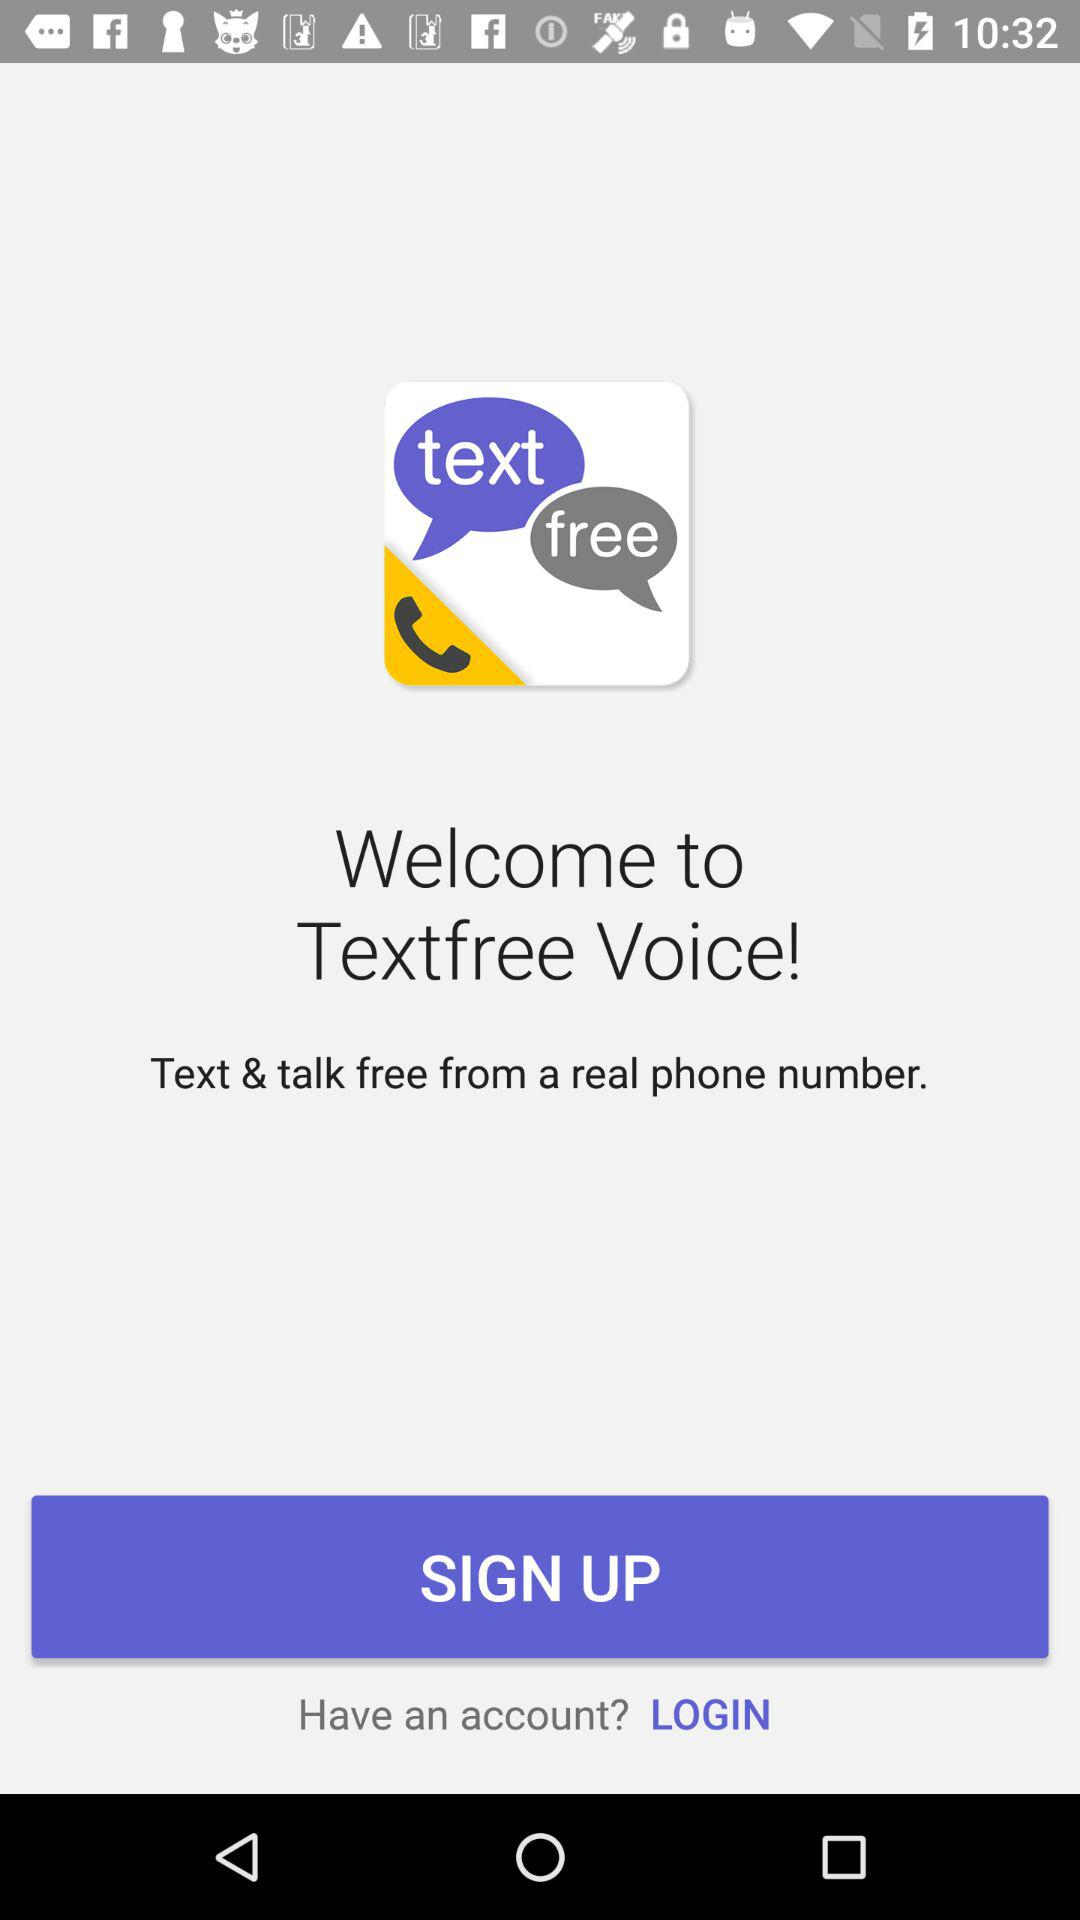What can we do with a real phone number? You can text and talk for free. 